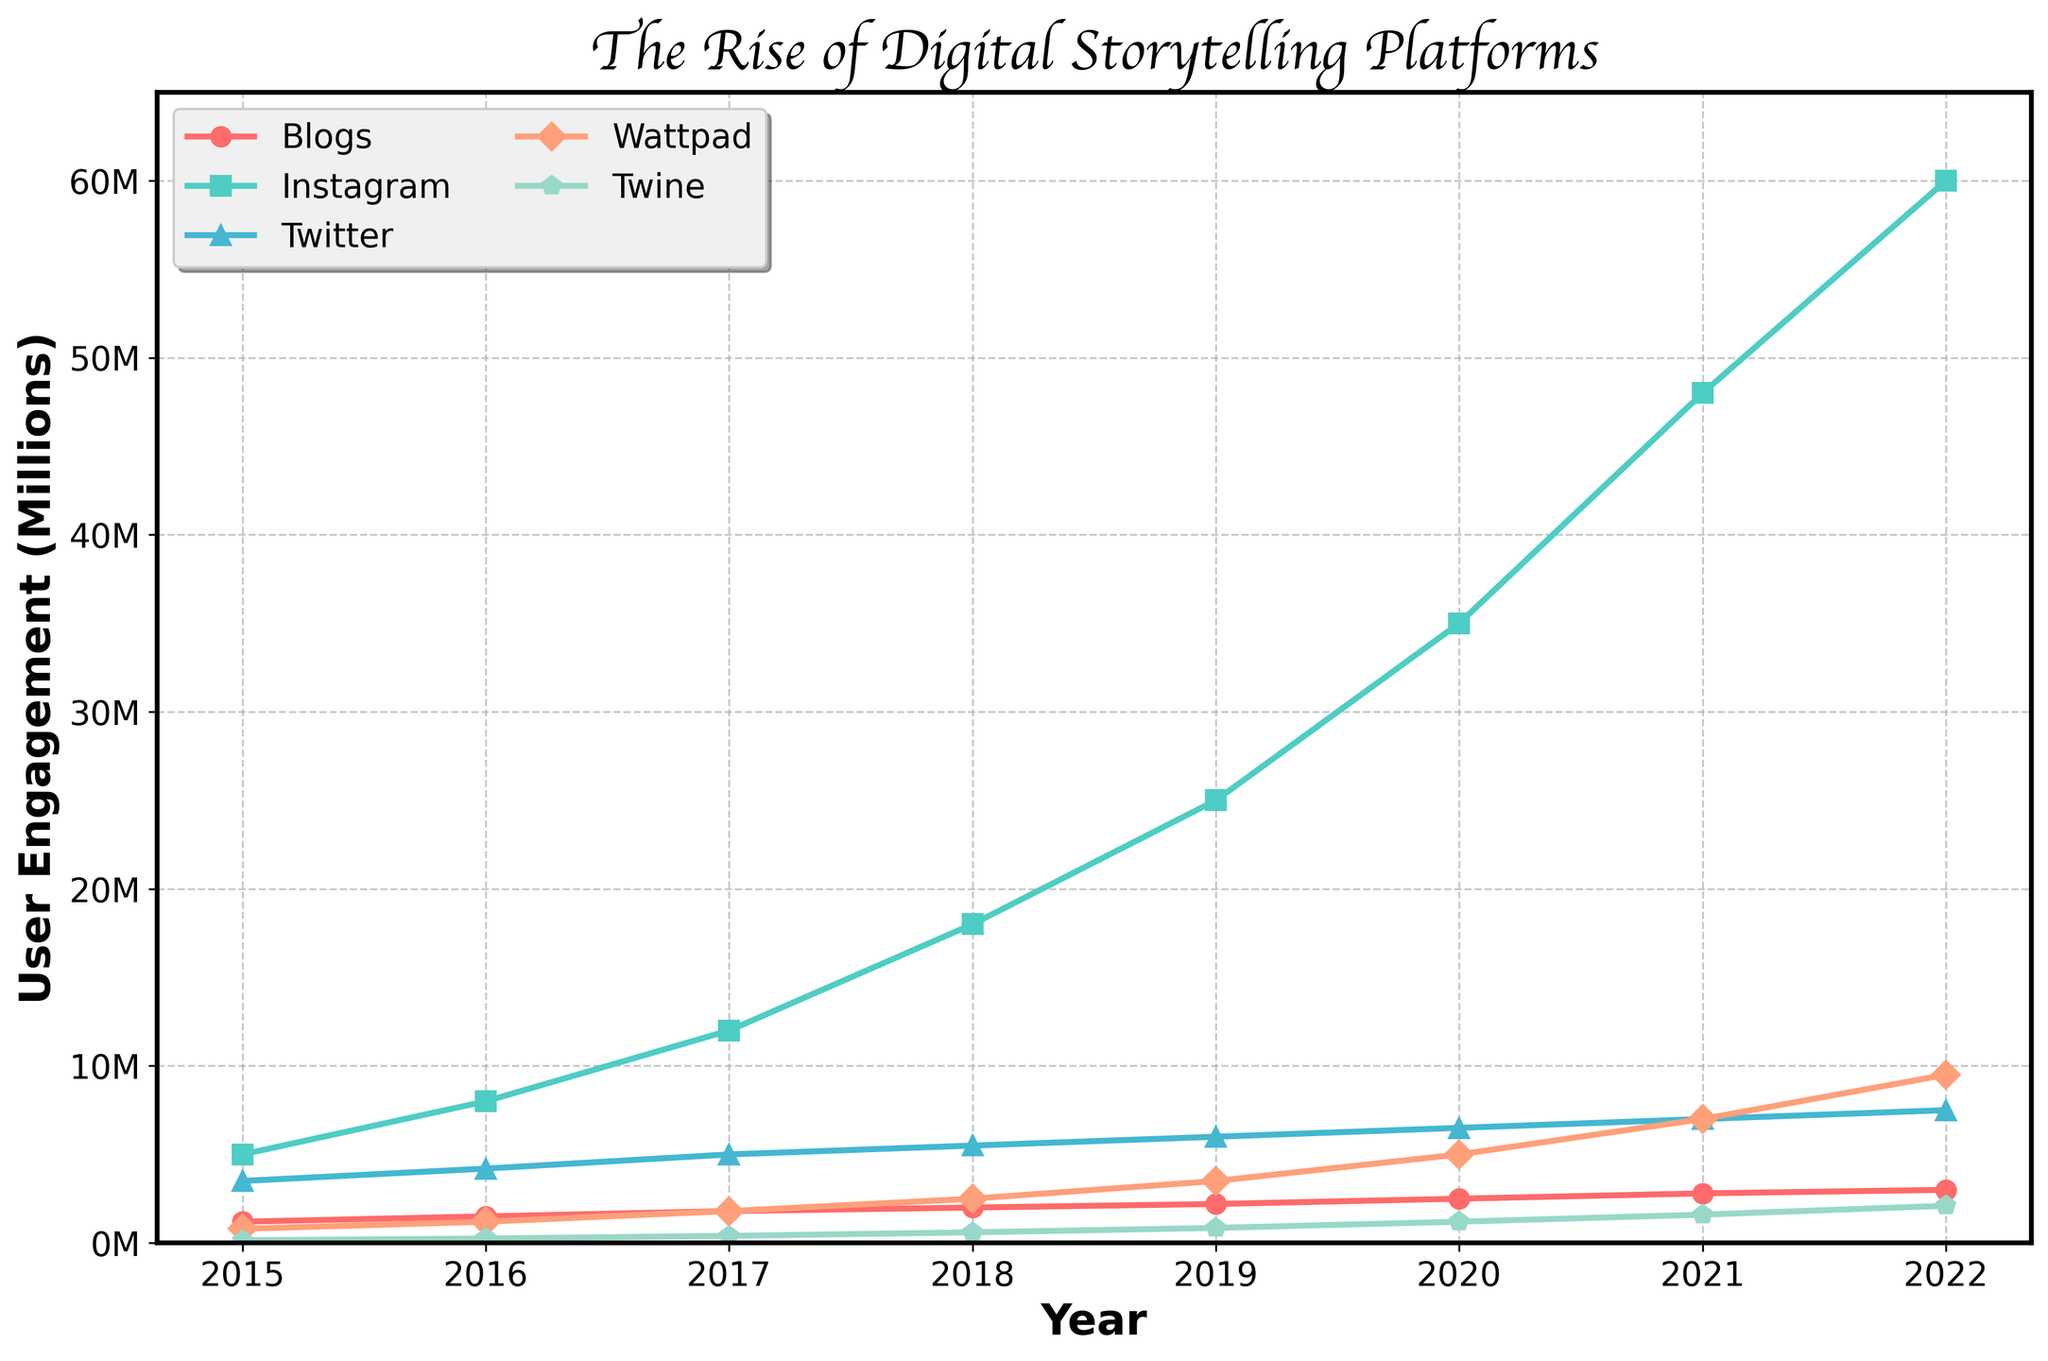Which platform had the highest user engagement in 2022? The figure shows that Instagram had the highest user engagement in 2022 as its line reaches the highest point on the right side of the plot.
Answer: Instagram How did the user engagement for Blogs change from 2015 to 2022? To find the change, subtract the 2015 value (1,200,000) from the 2022 value (3,000,000). The change is 3,000,000 - 1,200,000.
Answer: 1,800,000 Which platform showed the most significant increase in user engagement from 2015 to 2022? By observing the steepness of the lines and the difference in heights from the start to end, Instagram's user engagement increased from 5,000,000 to 60,000,000, the largest increase among all platforms.
Answer: Instagram In which year did Wattpad's user engagement exceed 3 million? By tracing Wattpad's line, it surpasses the 3 million mark in 2019, as indicated by the y-axis values and the position of the line.
Answer: 2019 What is the sum of user engagement for Twine and Wattpad in 2020? Add Twine's value (1,200,000) and Wattpad's value (5,000,000) for the year 2020.
Answer: 6,200,000 Which two platforms have the closest user engagement values in 2022? By comparing the lines' end points for 2022, Twitter (7,500,000) and Wattpad (9,500,000) are the closest in value.
Answer: Twitter and Wattpad What visual attributes differentiate the line for Blogs from the line for Twitter? The line for Blogs is marked with circles and is red, whereas the line for Twitter uses triangles and is blue.
Answer: Circles and red vs. triangles and blue What is the average user engagement for Instagram from 2015 to 2018? Sum the values for 2015, 2016, 2017, and 2018 (5,000,000 + 8,000,000 + 12,000,000 + 18,000,000), then divide by 4. The calculation is 43,000,000 / 4.
Answer: 10,750,000 Which platform showed the smallest increase in user engagement from 2015 to 2022? By observing the figure, Twine's increase is from 150,000 to 2,100,000, the smallest increase among all platforms.
Answer: Twine 